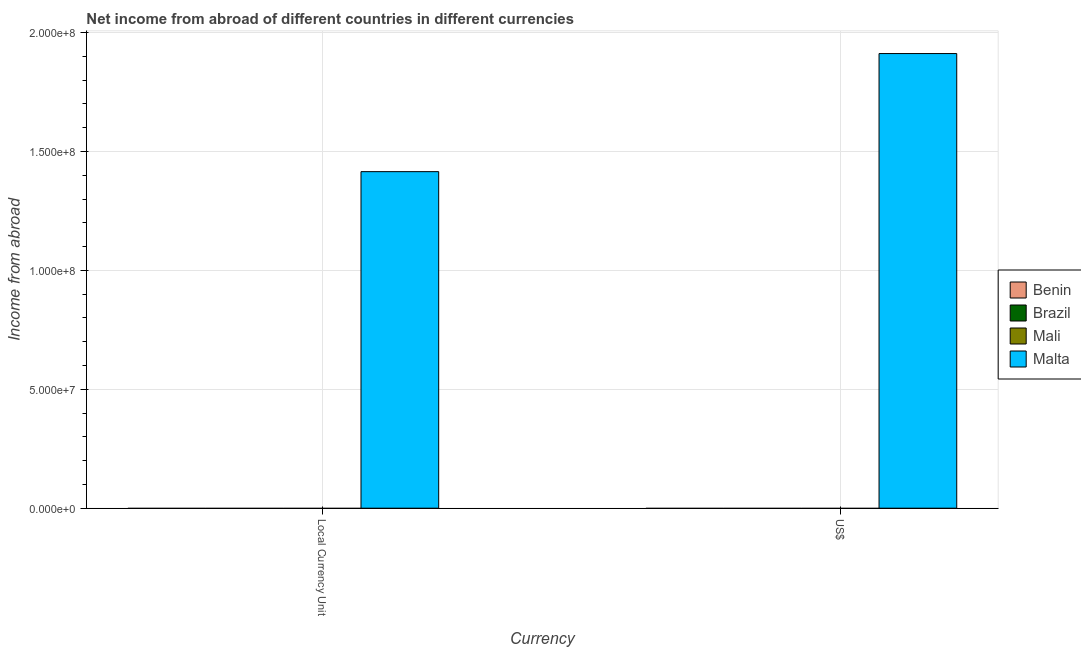How many different coloured bars are there?
Your answer should be very brief. 1. Are the number of bars on each tick of the X-axis equal?
Provide a succinct answer. Yes. How many bars are there on the 2nd tick from the right?
Keep it short and to the point. 1. What is the label of the 2nd group of bars from the left?
Ensure brevity in your answer.  US$. What is the income from abroad in us$ in Malta?
Your response must be concise. 1.91e+08. Across all countries, what is the maximum income from abroad in constant 2005 us$?
Give a very brief answer. 1.42e+08. Across all countries, what is the minimum income from abroad in us$?
Your response must be concise. 0. In which country was the income from abroad in us$ maximum?
Provide a succinct answer. Malta. What is the total income from abroad in us$ in the graph?
Make the answer very short. 1.91e+08. What is the difference between the income from abroad in constant 2005 us$ in Malta and the income from abroad in us$ in Brazil?
Ensure brevity in your answer.  1.42e+08. What is the average income from abroad in constant 2005 us$ per country?
Keep it short and to the point. 3.54e+07. In how many countries, is the income from abroad in constant 2005 us$ greater than 110000000 units?
Ensure brevity in your answer.  1. How many countries are there in the graph?
Provide a short and direct response. 4. Are the values on the major ticks of Y-axis written in scientific E-notation?
Give a very brief answer. Yes. Where does the legend appear in the graph?
Your answer should be compact. Center right. How are the legend labels stacked?
Provide a succinct answer. Vertical. What is the title of the graph?
Give a very brief answer. Net income from abroad of different countries in different currencies. Does "New Caledonia" appear as one of the legend labels in the graph?
Offer a terse response. No. What is the label or title of the X-axis?
Provide a short and direct response. Currency. What is the label or title of the Y-axis?
Your response must be concise. Income from abroad. What is the Income from abroad in Malta in Local Currency Unit?
Keep it short and to the point. 1.42e+08. What is the Income from abroad in Brazil in US$?
Give a very brief answer. 0. What is the Income from abroad in Mali in US$?
Provide a short and direct response. 0. What is the Income from abroad of Malta in US$?
Provide a short and direct response. 1.91e+08. Across all Currency, what is the maximum Income from abroad of Malta?
Ensure brevity in your answer.  1.91e+08. Across all Currency, what is the minimum Income from abroad in Malta?
Provide a succinct answer. 1.42e+08. What is the total Income from abroad of Brazil in the graph?
Your answer should be very brief. 0. What is the total Income from abroad in Mali in the graph?
Make the answer very short. 0. What is the total Income from abroad of Malta in the graph?
Keep it short and to the point. 3.33e+08. What is the difference between the Income from abroad in Malta in Local Currency Unit and that in US$?
Your answer should be compact. -4.97e+07. What is the average Income from abroad of Brazil per Currency?
Offer a very short reply. 0. What is the average Income from abroad in Malta per Currency?
Make the answer very short. 1.66e+08. What is the ratio of the Income from abroad of Malta in Local Currency Unit to that in US$?
Give a very brief answer. 0.74. What is the difference between the highest and the second highest Income from abroad of Malta?
Offer a very short reply. 4.97e+07. What is the difference between the highest and the lowest Income from abroad in Malta?
Provide a short and direct response. 4.97e+07. 